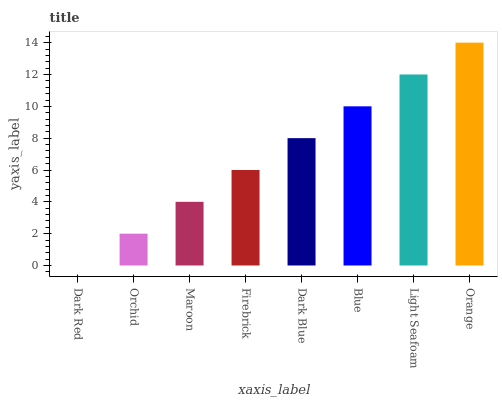Is Dark Red the minimum?
Answer yes or no. Yes. Is Orange the maximum?
Answer yes or no. Yes. Is Orchid the minimum?
Answer yes or no. No. Is Orchid the maximum?
Answer yes or no. No. Is Orchid greater than Dark Red?
Answer yes or no. Yes. Is Dark Red less than Orchid?
Answer yes or no. Yes. Is Dark Red greater than Orchid?
Answer yes or no. No. Is Orchid less than Dark Red?
Answer yes or no. No. Is Dark Blue the high median?
Answer yes or no. Yes. Is Firebrick the low median?
Answer yes or no. Yes. Is Dark Red the high median?
Answer yes or no. No. Is Dark Blue the low median?
Answer yes or no. No. 